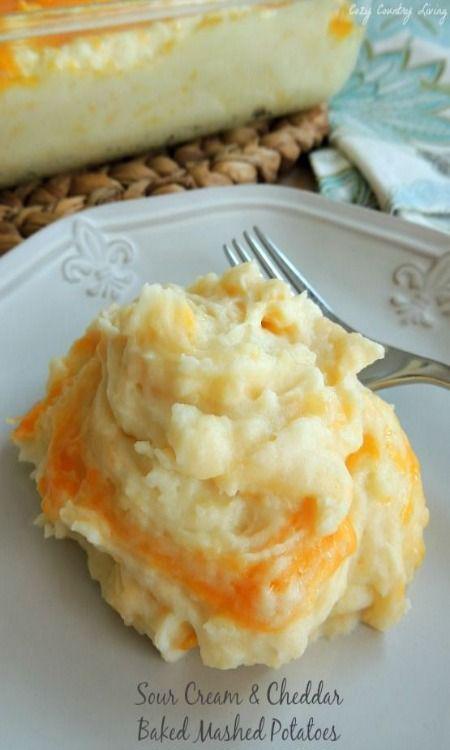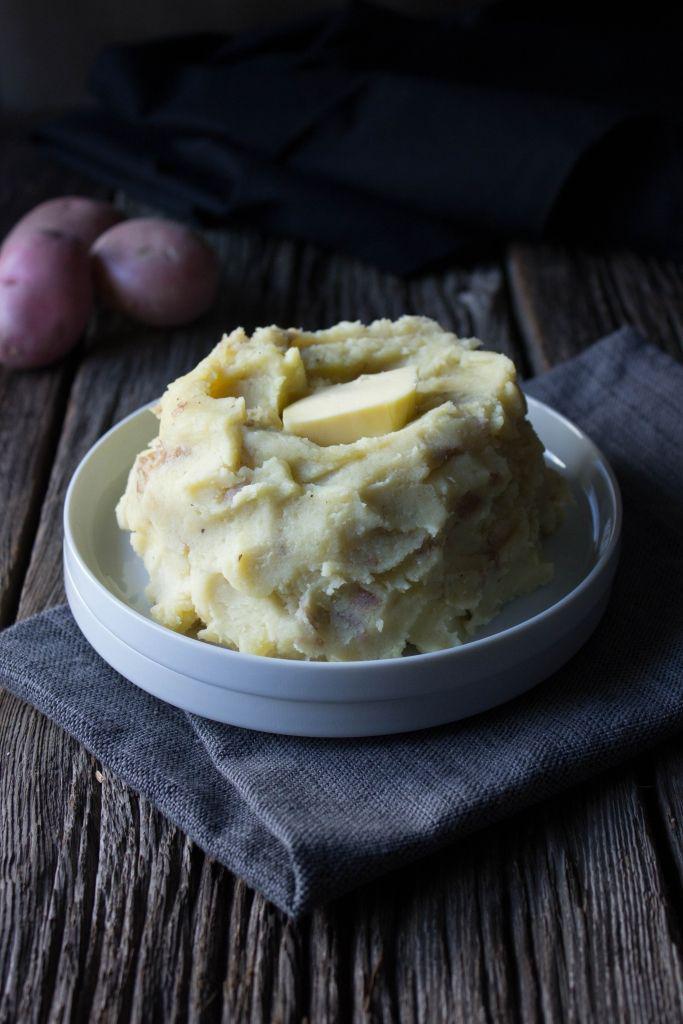The first image is the image on the left, the second image is the image on the right. Given the left and right images, does the statement "A spoon is in a bowl of mashed potatoes in one image." hold true? Answer yes or no. No. The first image is the image on the left, the second image is the image on the right. Given the left and right images, does the statement "In one image, there is a spoon in the mashed potatoes that is resting on the side of the container that the potatoes are in." hold true? Answer yes or no. No. 